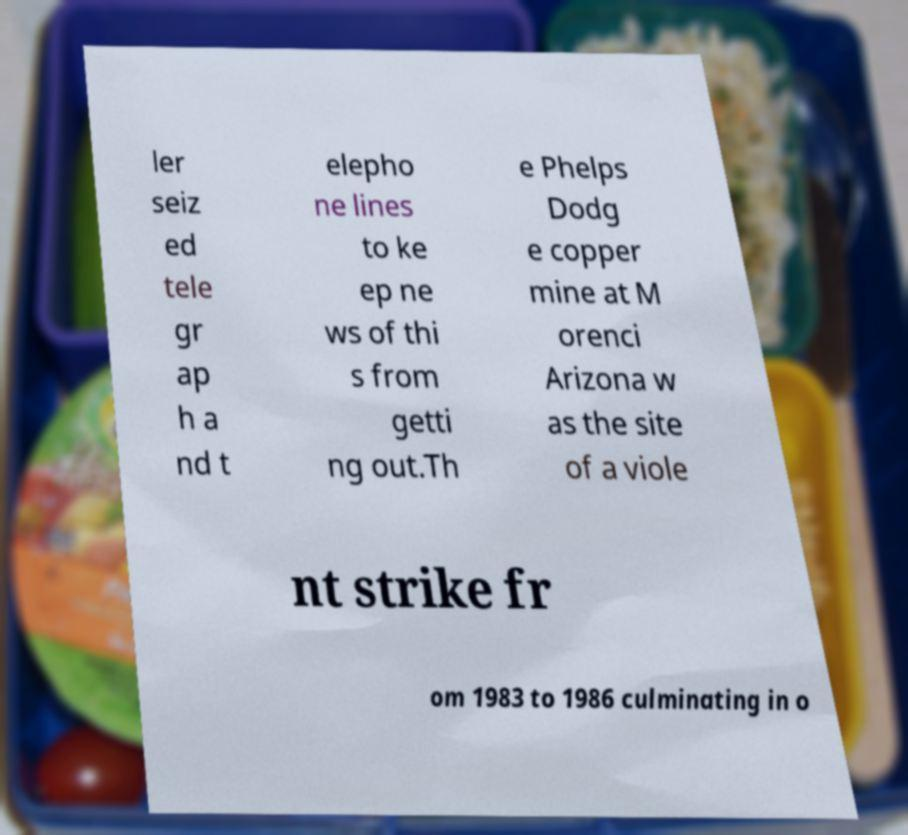Please read and relay the text visible in this image. What does it say? ler seiz ed tele gr ap h a nd t elepho ne lines to ke ep ne ws of thi s from getti ng out.Th e Phelps Dodg e copper mine at M orenci Arizona w as the site of a viole nt strike fr om 1983 to 1986 culminating in o 